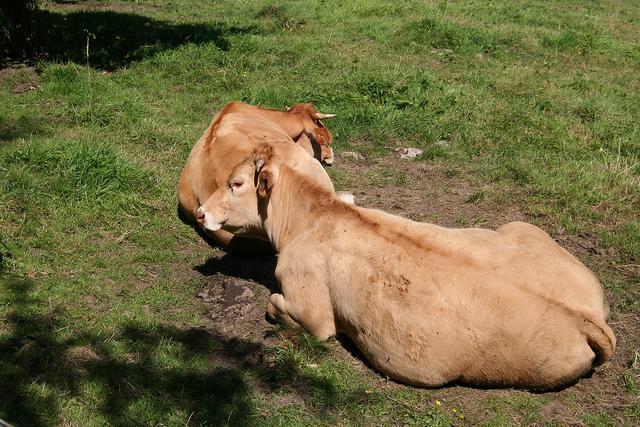How many cows can be seen?
Give a very brief answer. 2. How many people are wearing green black and white sneakers while riding a skateboard?
Give a very brief answer. 0. 